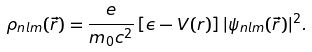<formula> <loc_0><loc_0><loc_500><loc_500>\rho _ { n l m } ( \vec { r } ) = \frac { e } { m _ { 0 } c ^ { 2 } } \left [ \epsilon - V ( r ) \right ] | \psi _ { n l m } ( \vec { r } ) | ^ { 2 } .</formula> 